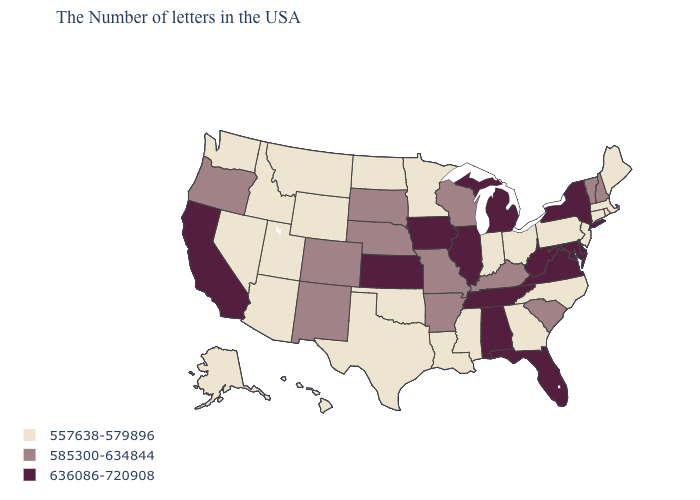Name the states that have a value in the range 636086-720908?
Concise answer only. New York, Delaware, Maryland, Virginia, West Virginia, Florida, Michigan, Alabama, Tennessee, Illinois, Iowa, Kansas, California. What is the lowest value in the USA?
Give a very brief answer. 557638-579896. Among the states that border Michigan , does Ohio have the lowest value?
Answer briefly. Yes. Is the legend a continuous bar?
Answer briefly. No. What is the highest value in states that border Massachusetts?
Short answer required. 636086-720908. What is the value of West Virginia?
Answer briefly. 636086-720908. Name the states that have a value in the range 585300-634844?
Quick response, please. New Hampshire, Vermont, South Carolina, Kentucky, Wisconsin, Missouri, Arkansas, Nebraska, South Dakota, Colorado, New Mexico, Oregon. Name the states that have a value in the range 585300-634844?
Keep it brief. New Hampshire, Vermont, South Carolina, Kentucky, Wisconsin, Missouri, Arkansas, Nebraska, South Dakota, Colorado, New Mexico, Oregon. Among the states that border Arkansas , does Tennessee have the highest value?
Write a very short answer. Yes. What is the value of Colorado?
Write a very short answer. 585300-634844. Which states have the highest value in the USA?
Quick response, please. New York, Delaware, Maryland, Virginia, West Virginia, Florida, Michigan, Alabama, Tennessee, Illinois, Iowa, Kansas, California. What is the highest value in the USA?
Quick response, please. 636086-720908. Is the legend a continuous bar?
Answer briefly. No. What is the highest value in the USA?
Answer briefly. 636086-720908. What is the value of Pennsylvania?
Keep it brief. 557638-579896. 